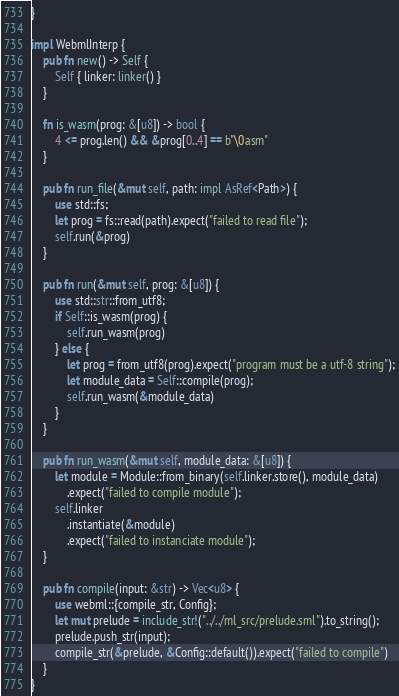Convert code to text. <code><loc_0><loc_0><loc_500><loc_500><_Rust_>}

impl WebmlInterp {
    pub fn new() -> Self {
        Self { linker: linker() }
    }

    fn is_wasm(prog: &[u8]) -> bool {
        4 <= prog.len() && &prog[0..4] == b"\0asm"
    }

    pub fn run_file(&mut self, path: impl AsRef<Path>) {
        use std::fs;
        let prog = fs::read(path).expect("failed to read file");
        self.run(&prog)
    }

    pub fn run(&mut self, prog: &[u8]) {
        use std::str::from_utf8;
        if Self::is_wasm(prog) {
            self.run_wasm(prog)
        } else {
            let prog = from_utf8(prog).expect("program must be a utf-8 string");
            let module_data = Self::compile(prog);
            self.run_wasm(&module_data)
        }
    }

    pub fn run_wasm(&mut self, module_data: &[u8]) {
        let module = Module::from_binary(self.linker.store(), module_data)
            .expect("failed to compile module");
        self.linker
            .instantiate(&module)
            .expect("failed to instanciate module");
    }

    pub fn compile(input: &str) -> Vec<u8> {
        use webml::{compile_str, Config};
        let mut prelude = include_str!("../../ml_src/prelude.sml").to_string();
        prelude.push_str(input);
        compile_str(&prelude, &Config::default()).expect("failed to compile")
    }
}
</code> 